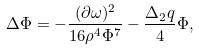<formula> <loc_0><loc_0><loc_500><loc_500>\Delta \Phi = - \frac { ( \partial \omega ) ^ { 2 } } { 1 6 \rho ^ { 4 } \Phi ^ { 7 } } - \frac { \Delta _ { 2 } q } { 4 } \Phi ,</formula> 